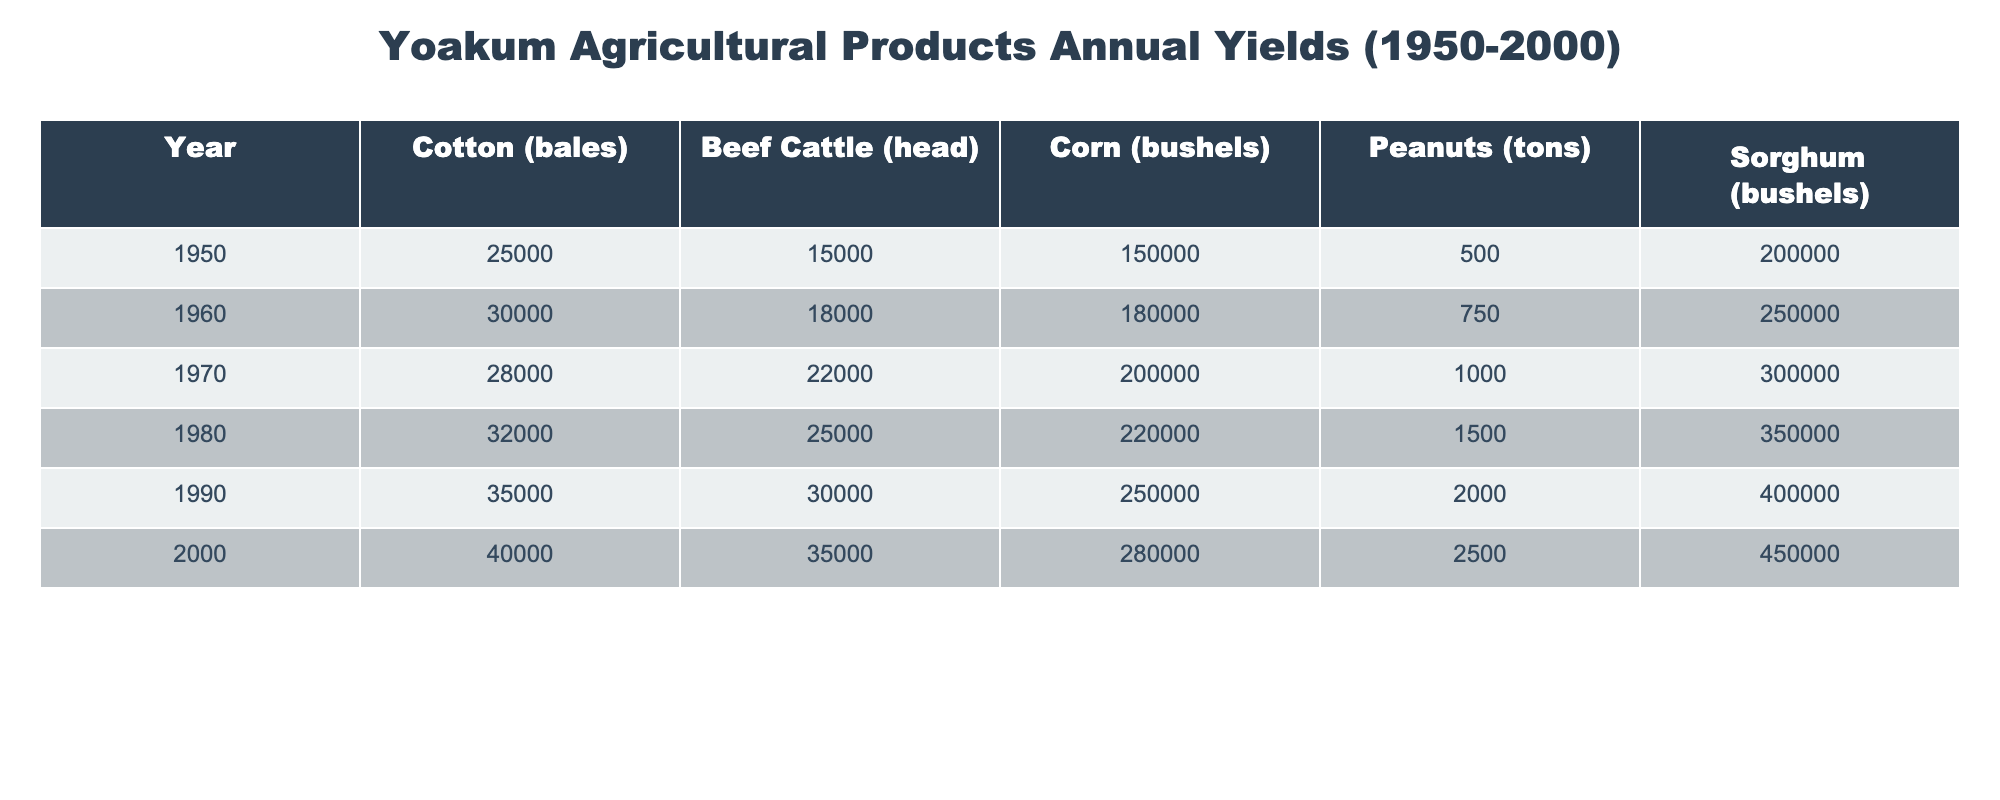What was the annual yield of Cotton in 1990? The table shows that the annual yield of Cotton in 1990 is 35,000 bales.
Answer: 35,000 bales Which agricultural product had the highest yield in 2000? In 2000, Sorghum had the highest yield of 450,000 bushels, compared to the other products.
Answer: Sorghum How much did the Beef Cattle yield increase from 1950 to 2000? The yield of Beef Cattle in 1950 was 15,000 head, and in 2000 it was 35,000 head. The increase is 35,000 - 15,000 = 20,000 head.
Answer: 20,000 head What was the average yield of Corn from 1950 to 2000? The yields of Corn from 1950 to 2000 are 150,000, 180,000, 200,000, 220,000, 250,000, and 280,000 bushels. The average is (150,000 + 180,000 + 200,000 + 220,000 + 250,000 + 280,000) / 6 = 226,666.67 bushels.
Answer: 226,666.67 bushels Did the yield of Peanuts increase every decade from 1950 to 2000? In the table, the yield of Peanuts was 500 tons in 1950, 750 tons in 1960, 1,000 tons in 1970, 1,500 tons in 1980, 2,000 tons in 1990, and 2,500 tons in 2000. Since all the values are increasing, the answer is yes.
Answer: Yes What was the total yield of all five products in 1990? To find the total yield in 1990, sum the yields of all products: 35,000 (Cotton) + 30,000 (Beef Cattle) + 250,000 (Corn) + 2,000 (Peanuts) + 400,000 (Sorghum) = 717,000.
Answer: 717,000 In which decade did Sorghum first exceed 300,000 bushels in yield? By checking the yields, Sorghum was at 300,000 bushels in 1970 and exceeded this amount in 1980 with 350,000 bushels. Thus, after the 1970s, it exceeded 300,000 bushels.
Answer: 1980s What was the yield of Beef Cattle in 1970 compared to 1960? In 1970, the yield of Beef Cattle was 22,000 head and in 1960 it was 18,000 head, which means it increased by 22,000 - 18,000 = 4,000 head from 1960 to 1970.
Answer: Increased by 4,000 head What was the percentage increase in Cotton yield from 1950 to 2000? The yield of Cotton was 25,000 bales in 1950 and 40,000 bales in 2000. The percentage increase is ((40,000 - 25,000) / 25,000) * 100 = 60%.
Answer: 60% 